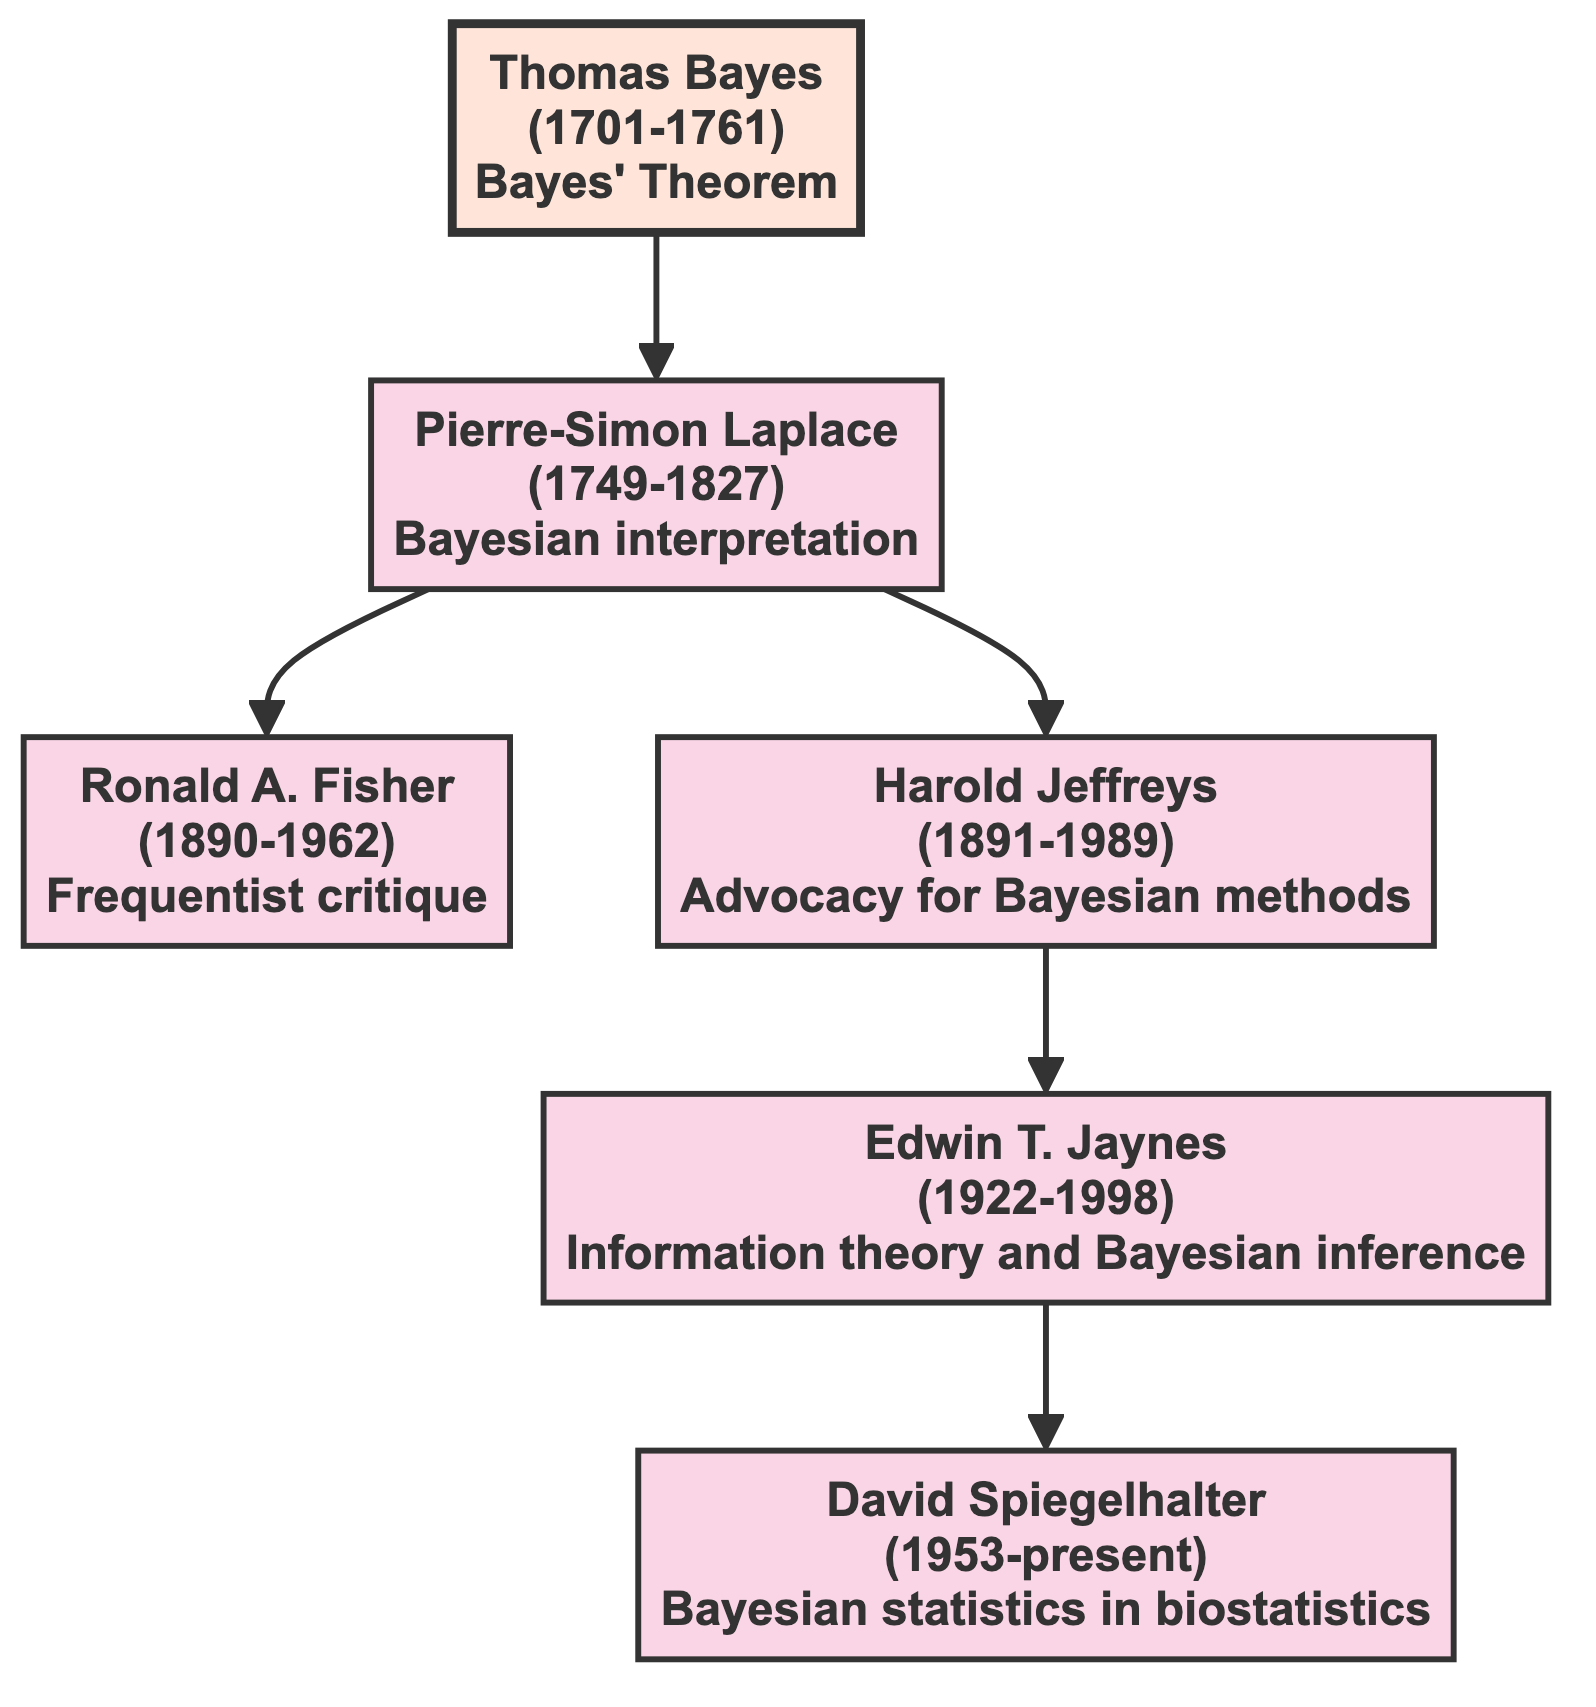What is the lifespan of Thomas Bayes? The diagram specifies the lifespan of Thomas Bayes as 1701-1761, which is displayed in his node.
Answer: 1701-1761 Who directly succeeded Pierre-Simon Laplace in the genealogy? From the diagram, Pierre-Simon Laplace has two direct successors: Ronald A. Fisher and Harold Jeffreys. However, the question asks about the immediate successor, which is Ronald A. Fisher as he is listed first after Laplace.
Answer: Ronald A. Fisher How many notable works are associated with Edwin T. Jaynes? The diagram provides information that Edwin T. Jaynes has one notable work, titled "Probability Theory: The Logic of Science" indicated in his node.
Answer: 1 What was Harold Jeffreys' primary contribution? In the diagram, Harold Jeffreys is associated with the advocacy for Bayesian methods, which is mentioned directly in his node.
Answer: Advocacy for Bayesian methods Which author contributed to both Bayesian statistics and Bayesian inference? The analysis of the diagram shows that Edwin T. Jaynes contributed to Bayesian inference, while David Spiegelhalter contributed to Bayesian statistics, but both are involved in Bayesian concepts. However, only one author is addressing Bayesian inference specifically, thus the answer would focus on him.
Answer: Edwin T. Jaynes Which author follows Thomas Bayes in the diagram? Looking at the flow from Thomas Bayes in the diagram, Pierre-Simon Laplace directly follows him, representing the next generation in the genealogy.
Answer: Pierre-Simon Laplace How many generations are represented in the diagram? The diagram indicates Thomas Bayes as the root (first generation), followed by Pierre-Simon Laplace (second generation), and then Ronald A. Fisher, Harold Jeffreys, Edwin T. Jaynes, and David Spiegelhalter (third generation), making it a total of three generations.
Answer: 3 What type of inference is Edwin T. Jaynes associated with? The diagram specifies Edwin T. Jaynes as contributing to the area of information theory and Bayesian inference as described in his node.
Answer: Bayesian inference 